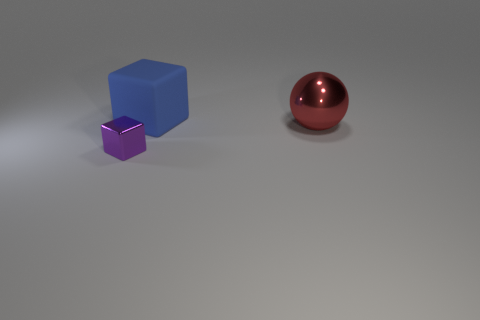The ball that is the same size as the blue matte cube is what color?
Offer a terse response. Red. There is a thing that is both to the right of the small purple object and in front of the big blue cube; what is its color?
Provide a succinct answer. Red. What size is the block in front of the big object behind the thing that is to the right of the blue matte cube?
Provide a short and direct response. Small. What material is the big block?
Keep it short and to the point. Rubber. Is the red thing made of the same material as the large thing left of the red object?
Keep it short and to the point. No. Is there a big matte block that is behind the cube behind the metallic object that is on the right side of the purple block?
Provide a succinct answer. No. The tiny block is what color?
Your response must be concise. Purple. There is a tiny purple metal object; are there any large red metallic objects behind it?
Make the answer very short. Yes. Is the shape of the blue thing the same as the object in front of the red sphere?
Give a very brief answer. Yes. How many other objects are the same material as the large red sphere?
Offer a very short reply. 1. 